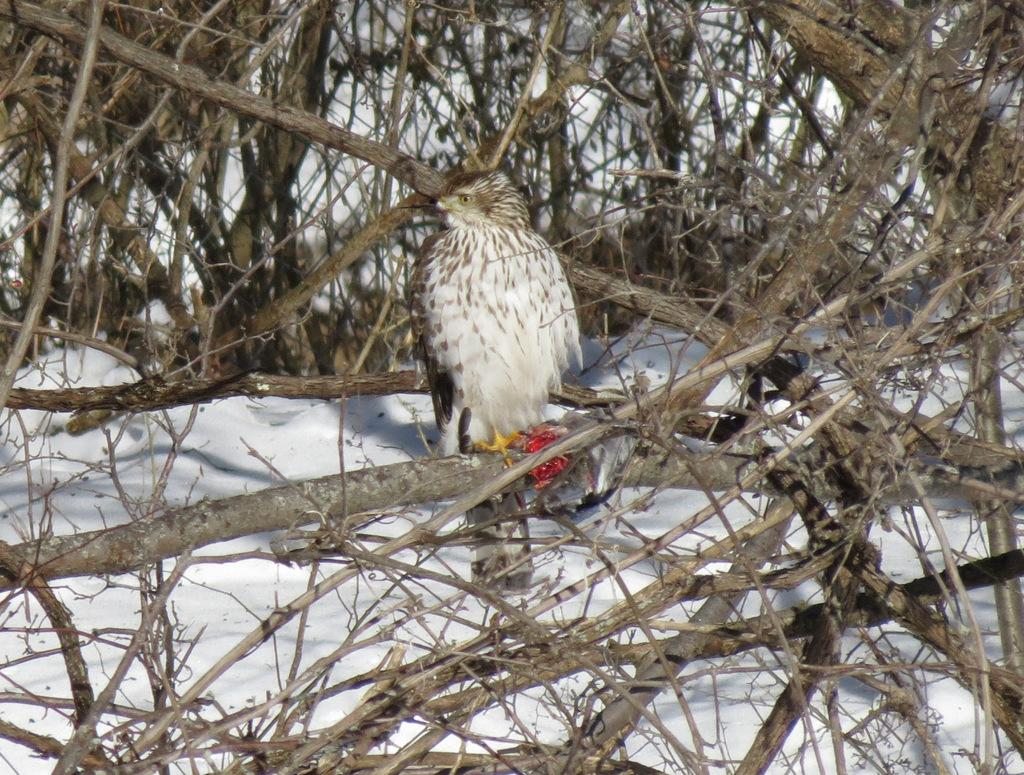What type of animal can be seen in the image? There is a bird in the image. Where is the bird located? The bird is standing on a tree stem. What can be seen in the background of the image? There is an iceberg in the background of the image. What is the color of the iceberg? The iceberg is white in color. Is there a cable attached to the bird in the image? No, there is no cable attached to the bird in the image. Can the bird be seen flying in the image? No, the bird is standing on a tree stem, not flying. 